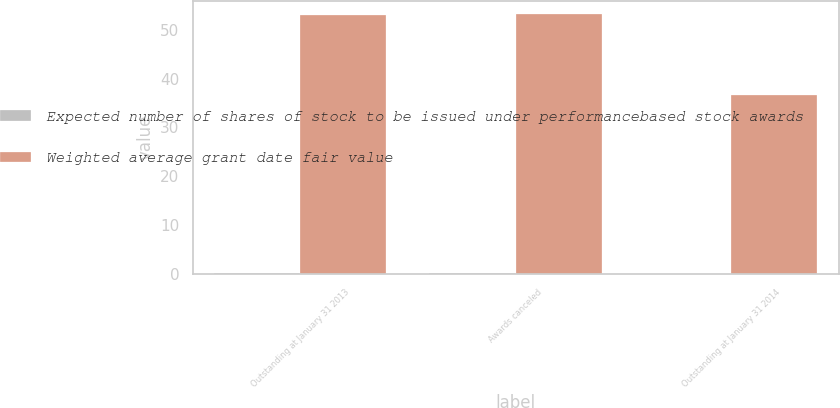<chart> <loc_0><loc_0><loc_500><loc_500><stacked_bar_chart><ecel><fcel>Outstanding at January 31 2013<fcel>Awards canceled<fcel>Outstanding at January 31 2014<nl><fcel>Expected number of shares of stock to be issued under performancebased stock awards<fcel>0.3<fcel>0.2<fcel>0.1<nl><fcel>Weighted average grant date fair value<fcel>52.96<fcel>53.11<fcel>36.66<nl></chart> 